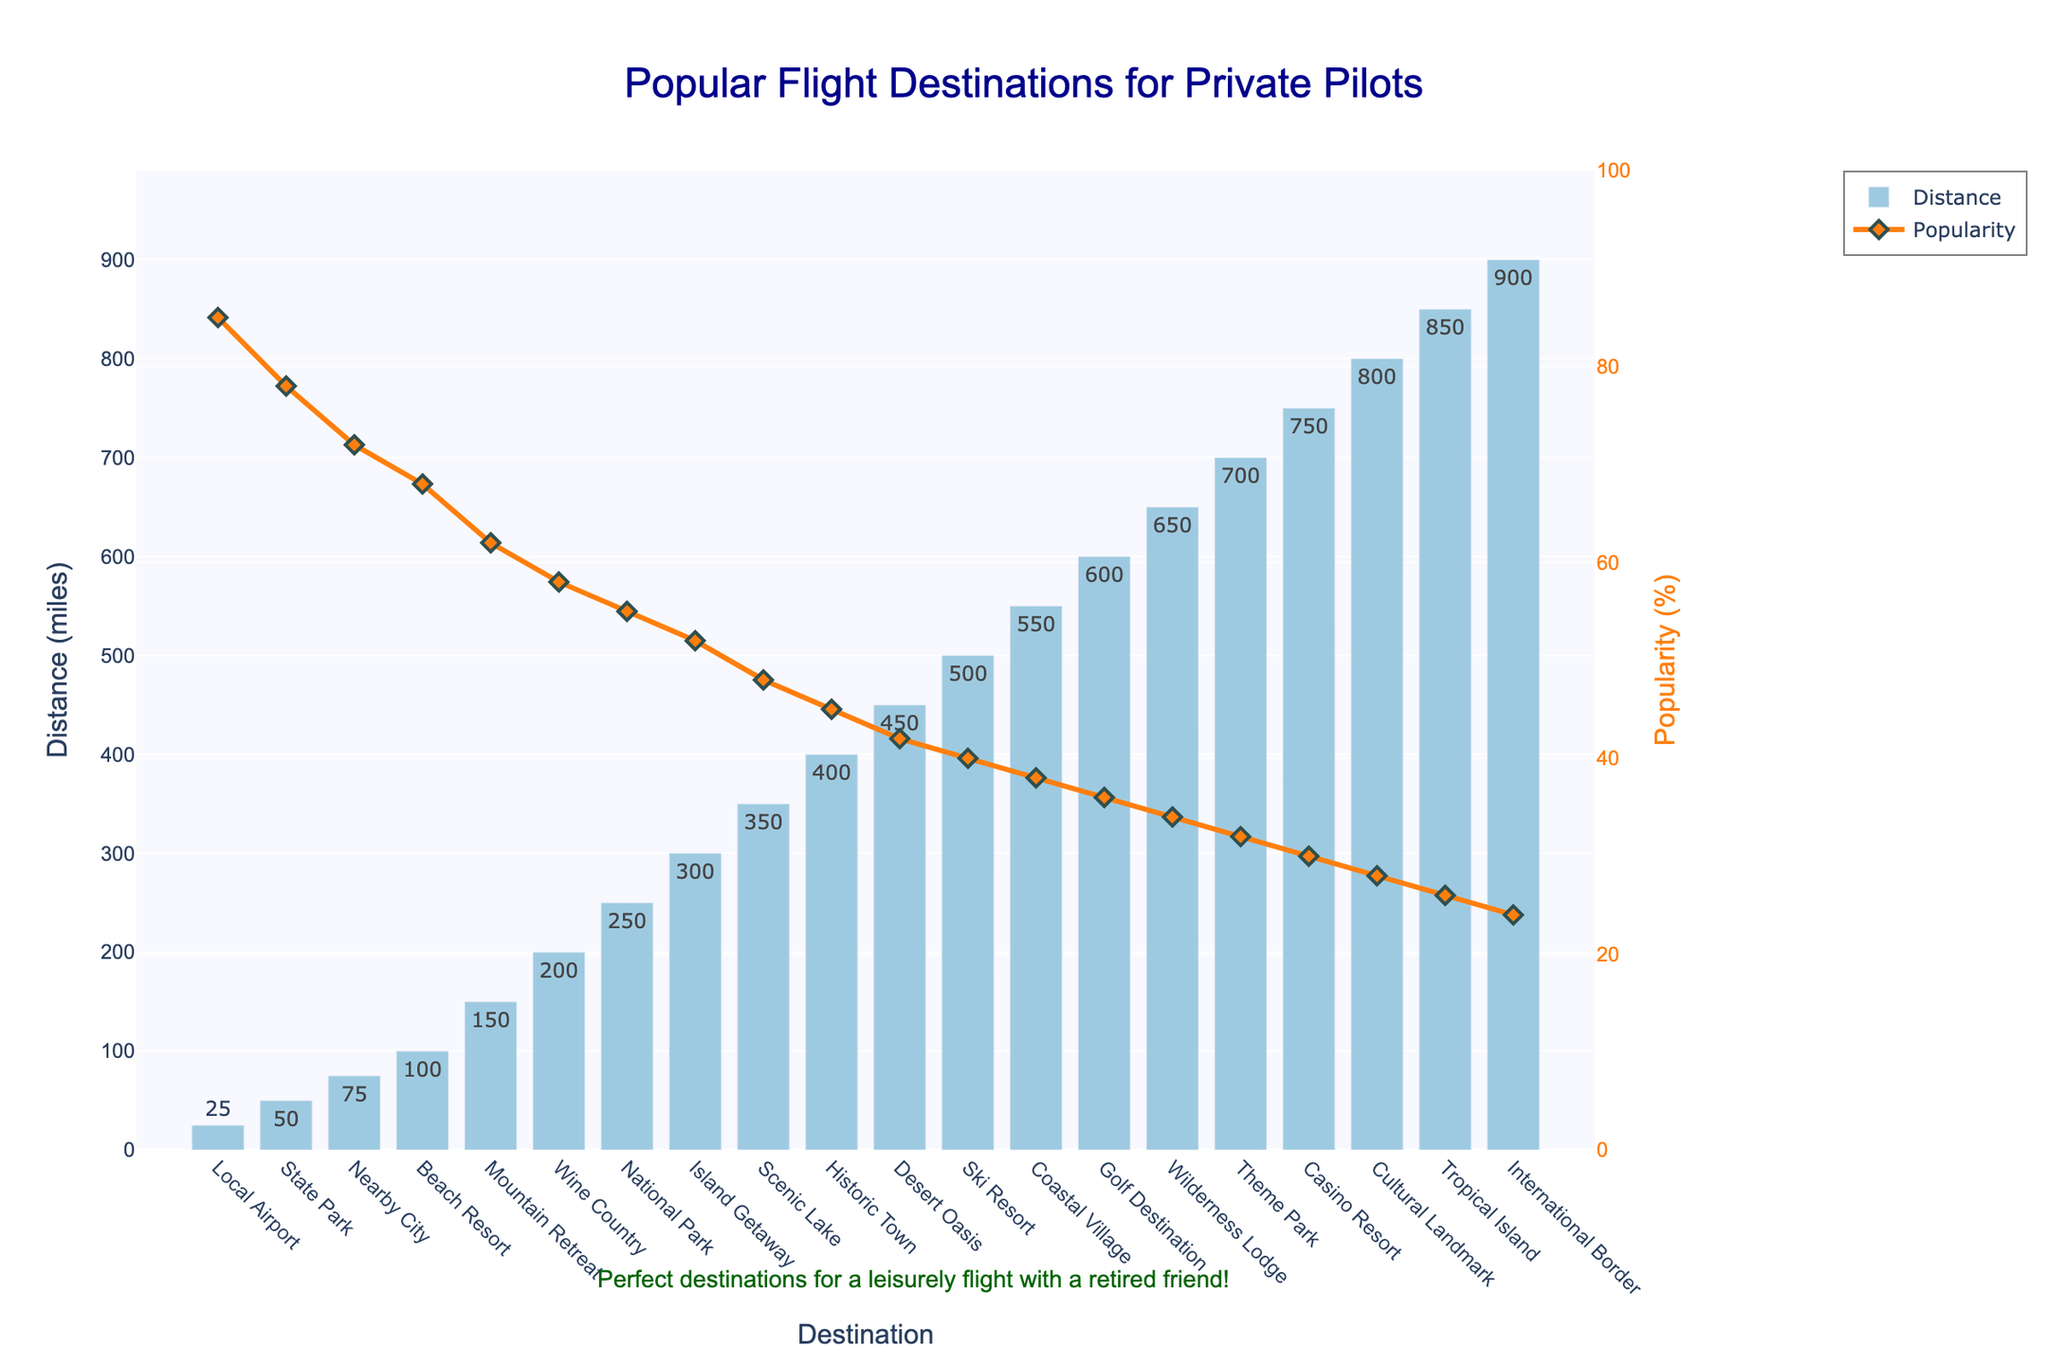Which destination is the closest to major cities? The destination with the shortest bar in the distance category is the Local Airport. According to the y-axis on the left, its distance is 25 miles.
Answer: Local Airport Which destination has the highest popularity percentage? The highest point in the line chart represents the highest popularity percentage. The destination at this peak is the Local Airport with 85% popularity, as indicated on the y-axis on the right.
Answer: Local Airport How much more popular is the State Park than the Ski Resort? The popularity of the State Park is indicated as 78%, and the Ski Resort is 40%. The difference in popularity can be calculated as 78% - 40% = 38%.
Answer: 38% What is the average distance of the destinations Local Airport, State Park, and Wine Country? The distances are 25 miles for the Local Airport, 50 miles for the State Park, and 200 miles for Wine Country. Their sum is 25 + 50 + 200 = 275 miles. Dividing this sum by the number of destinations, we get the average distance as 275/3 ≈ 91.67 miles.
Answer: 91.67 miles Which is less popular, the Tropical Island or the International Border? According to the line chart, the popularity percentage of Tropical Island is 26%, while the International Border is 24%. Therefore, the International Border is less popular.
Answer: International Border What is the total distance for the first five destinations? The distances for the first five destinations (Local Airport, State Park, Nearby City, Beach Resort, Mountain Retreat) are 25, 50, 75, 100, and 150 miles, respectively. The sum is 25 + 50 + 75 + 100 + 150 = 400 miles.
Answer: 400 miles Compare the distances to the nearest multiple of 50 miles and identify any pair of destinations equidistant on the nearest 50-mile mark. For the nearest multiple of 50, Local Airport and State Park are equidistant at 50 miles. Similarly, Beach Resort and Mountain Retreat are roughly at 100 and 150 miles, both rounding to 150 miles.
Answer: Local Airport and State Park Which destination has the lowest popularity percentage and what is its distance? The lowest point in the line chart represents the least popular destination, which is the International Border with a 24% popularity. The corresponding bar shows a distance of 900 miles.
Answer: International Border (900 miles) How does the popularity trend change as the distance increases? Observing the line chart, the general trend is a decrease in popularity as the distance increases. The highest popularity is at the shortest distance and it declines steadily with increasing miles.
Answer: Decreases 